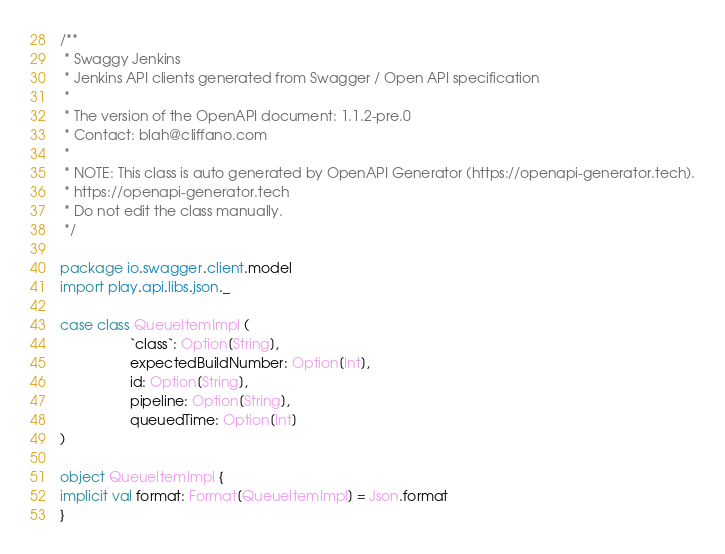Convert code to text. <code><loc_0><loc_0><loc_500><loc_500><_Scala_>/**
 * Swaggy Jenkins
 * Jenkins API clients generated from Swagger / Open API specification
 *
 * The version of the OpenAPI document: 1.1.2-pre.0
 * Contact: blah@cliffano.com
 *
 * NOTE: This class is auto generated by OpenAPI Generator (https://openapi-generator.tech).
 * https://openapi-generator.tech
 * Do not edit the class manually.
 */

package io.swagger.client.model
import play.api.libs.json._

case class QueueItemImpl (
                  `class`: Option[String],
                  expectedBuildNumber: Option[Int],
                  id: Option[String],
                  pipeline: Option[String],
                  queuedTime: Option[Int]
)

object QueueItemImpl {
implicit val format: Format[QueueItemImpl] = Json.format
}

</code> 